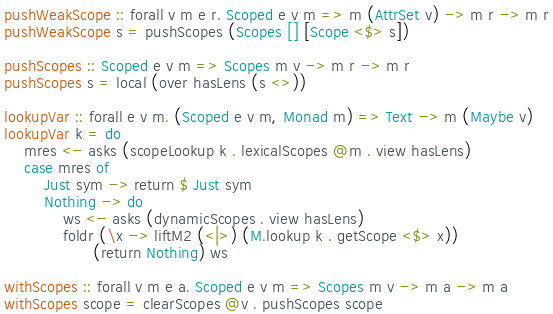<code> <loc_0><loc_0><loc_500><loc_500><_Haskell_>pushWeakScope :: forall v m e r. Scoped e v m => m (AttrSet v) -> m r -> m r
pushWeakScope s = pushScopes (Scopes [] [Scope <$> s])

pushScopes :: Scoped e v m => Scopes m v -> m r -> m r
pushScopes s = local (over hasLens (s <>))

lookupVar :: forall e v m. (Scoped e v m, Monad m) => Text -> m (Maybe v)
lookupVar k = do
    mres <- asks (scopeLookup k . lexicalScopes @m . view hasLens)
    case mres of
        Just sym -> return $ Just sym
        Nothing -> do
            ws <- asks (dynamicScopes . view hasLens)
            foldr (\x -> liftM2 (<|>) (M.lookup k . getScope <$> x))
                  (return Nothing) ws

withScopes :: forall v m e a. Scoped e v m => Scopes m v -> m a -> m a
withScopes scope = clearScopes @v . pushScopes scope
</code> 